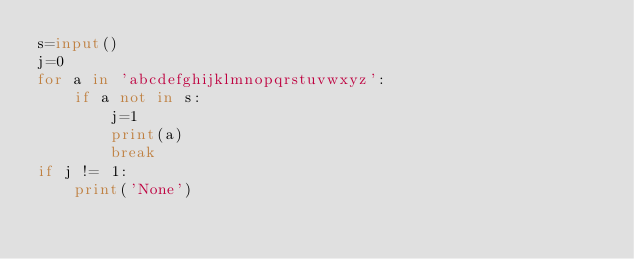<code> <loc_0><loc_0><loc_500><loc_500><_Python_>s=input()
j=0
for a in 'abcdefghijklmnopqrstuvwxyz':
    if a not in s:
        j=1
        print(a)
        break
if j != 1:
    print('None')</code> 